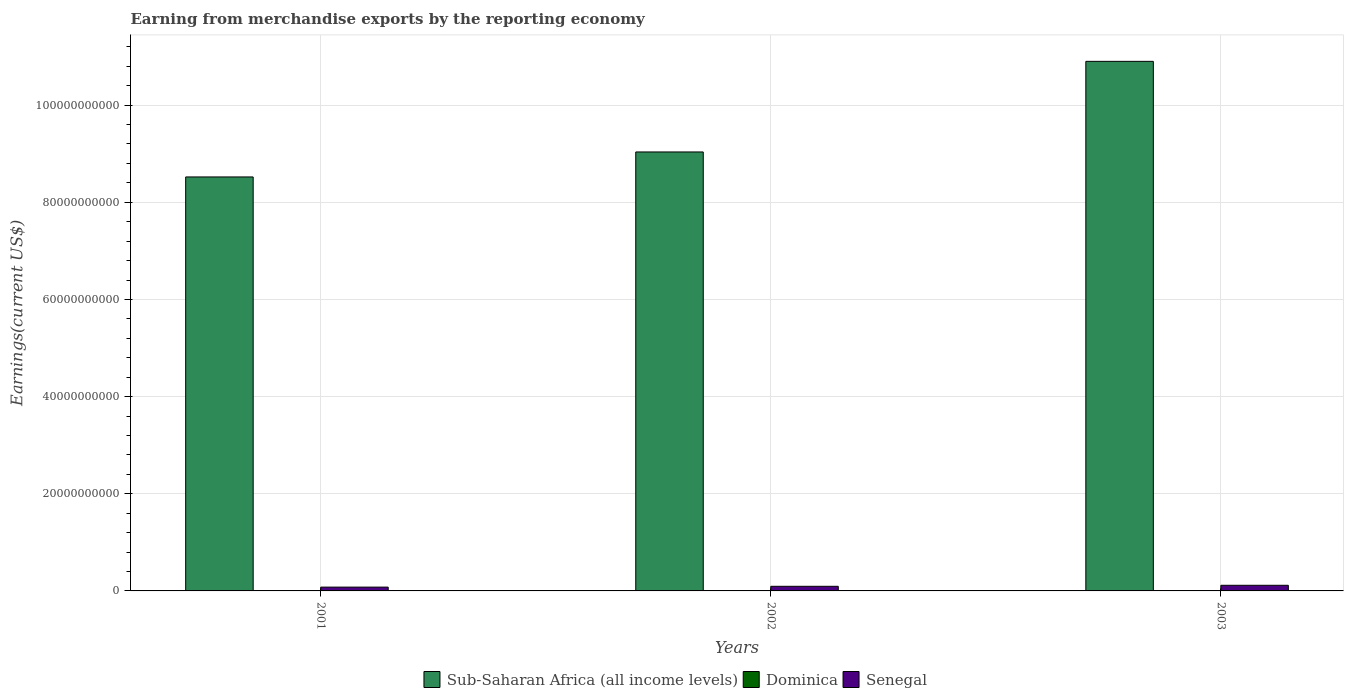How many different coloured bars are there?
Your response must be concise. 3. How many groups of bars are there?
Your answer should be compact. 3. What is the label of the 3rd group of bars from the left?
Offer a very short reply. 2003. In how many cases, is the number of bars for a given year not equal to the number of legend labels?
Provide a succinct answer. 0. What is the amount earned from merchandise exports in Dominica in 2003?
Provide a short and direct response. 6.10e+07. Across all years, what is the maximum amount earned from merchandise exports in Dominica?
Give a very brief answer. 6.10e+07. Across all years, what is the minimum amount earned from merchandise exports in Sub-Saharan Africa (all income levels)?
Ensure brevity in your answer.  8.52e+1. In which year was the amount earned from merchandise exports in Senegal maximum?
Your response must be concise. 2003. In which year was the amount earned from merchandise exports in Dominica minimum?
Keep it short and to the point. 2001. What is the total amount earned from merchandise exports in Senegal in the graph?
Offer a terse response. 2.89e+09. What is the difference between the amount earned from merchandise exports in Dominica in 2001 and that in 2002?
Your response must be concise. -1.71e+07. What is the difference between the amount earned from merchandise exports in Sub-Saharan Africa (all income levels) in 2003 and the amount earned from merchandise exports in Senegal in 2001?
Ensure brevity in your answer.  1.08e+11. What is the average amount earned from merchandise exports in Senegal per year?
Provide a short and direct response. 9.64e+08. In the year 2003, what is the difference between the amount earned from merchandise exports in Dominica and amount earned from merchandise exports in Sub-Saharan Africa (all income levels)?
Provide a short and direct response. -1.09e+11. What is the ratio of the amount earned from merchandise exports in Sub-Saharan Africa (all income levels) in 2001 to that in 2003?
Your answer should be very brief. 0.78. Is the difference between the amount earned from merchandise exports in Dominica in 2002 and 2003 greater than the difference between the amount earned from merchandise exports in Sub-Saharan Africa (all income levels) in 2002 and 2003?
Give a very brief answer. Yes. What is the difference between the highest and the second highest amount earned from merchandise exports in Senegal?
Offer a very short reply. 2.10e+08. What is the difference between the highest and the lowest amount earned from merchandise exports in Dominica?
Your answer should be very brief. 1.74e+07. Is the sum of the amount earned from merchandise exports in Sub-Saharan Africa (all income levels) in 2001 and 2002 greater than the maximum amount earned from merchandise exports in Senegal across all years?
Ensure brevity in your answer.  Yes. What does the 1st bar from the left in 2001 represents?
Provide a succinct answer. Sub-Saharan Africa (all income levels). What does the 3rd bar from the right in 2003 represents?
Offer a terse response. Sub-Saharan Africa (all income levels). How many bars are there?
Provide a succinct answer. 9. Are all the bars in the graph horizontal?
Your response must be concise. No. What is the difference between two consecutive major ticks on the Y-axis?
Make the answer very short. 2.00e+1. Are the values on the major ticks of Y-axis written in scientific E-notation?
Your answer should be compact. No. Does the graph contain any zero values?
Provide a succinct answer. No. How many legend labels are there?
Your response must be concise. 3. What is the title of the graph?
Your answer should be compact. Earning from merchandise exports by the reporting economy. Does "Bahrain" appear as one of the legend labels in the graph?
Provide a succinct answer. No. What is the label or title of the X-axis?
Ensure brevity in your answer.  Years. What is the label or title of the Y-axis?
Offer a terse response. Earnings(current US$). What is the Earnings(current US$) of Sub-Saharan Africa (all income levels) in 2001?
Give a very brief answer. 8.52e+1. What is the Earnings(current US$) in Dominica in 2001?
Make the answer very short. 4.35e+07. What is the Earnings(current US$) in Senegal in 2001?
Provide a succinct answer. 7.84e+08. What is the Earnings(current US$) of Sub-Saharan Africa (all income levels) in 2002?
Keep it short and to the point. 9.04e+1. What is the Earnings(current US$) in Dominica in 2002?
Keep it short and to the point. 6.06e+07. What is the Earnings(current US$) in Senegal in 2002?
Offer a very short reply. 9.49e+08. What is the Earnings(current US$) in Sub-Saharan Africa (all income levels) in 2003?
Your answer should be compact. 1.09e+11. What is the Earnings(current US$) of Dominica in 2003?
Keep it short and to the point. 6.10e+07. What is the Earnings(current US$) of Senegal in 2003?
Your response must be concise. 1.16e+09. Across all years, what is the maximum Earnings(current US$) in Sub-Saharan Africa (all income levels)?
Make the answer very short. 1.09e+11. Across all years, what is the maximum Earnings(current US$) in Dominica?
Provide a short and direct response. 6.10e+07. Across all years, what is the maximum Earnings(current US$) in Senegal?
Make the answer very short. 1.16e+09. Across all years, what is the minimum Earnings(current US$) of Sub-Saharan Africa (all income levels)?
Offer a very short reply. 8.52e+1. Across all years, what is the minimum Earnings(current US$) in Dominica?
Your answer should be very brief. 4.35e+07. Across all years, what is the minimum Earnings(current US$) in Senegal?
Your response must be concise. 7.84e+08. What is the total Earnings(current US$) in Sub-Saharan Africa (all income levels) in the graph?
Offer a terse response. 2.85e+11. What is the total Earnings(current US$) in Dominica in the graph?
Give a very brief answer. 1.65e+08. What is the total Earnings(current US$) of Senegal in the graph?
Make the answer very short. 2.89e+09. What is the difference between the Earnings(current US$) in Sub-Saharan Africa (all income levels) in 2001 and that in 2002?
Keep it short and to the point. -5.14e+09. What is the difference between the Earnings(current US$) in Dominica in 2001 and that in 2002?
Offer a terse response. -1.71e+07. What is the difference between the Earnings(current US$) of Senegal in 2001 and that in 2002?
Make the answer very short. -1.65e+08. What is the difference between the Earnings(current US$) of Sub-Saharan Africa (all income levels) in 2001 and that in 2003?
Your answer should be very brief. -2.38e+1. What is the difference between the Earnings(current US$) in Dominica in 2001 and that in 2003?
Provide a short and direct response. -1.74e+07. What is the difference between the Earnings(current US$) in Senegal in 2001 and that in 2003?
Your answer should be compact. -3.75e+08. What is the difference between the Earnings(current US$) in Sub-Saharan Africa (all income levels) in 2002 and that in 2003?
Give a very brief answer. -1.86e+1. What is the difference between the Earnings(current US$) in Dominica in 2002 and that in 2003?
Make the answer very short. -3.49e+05. What is the difference between the Earnings(current US$) in Senegal in 2002 and that in 2003?
Your answer should be compact. -2.10e+08. What is the difference between the Earnings(current US$) in Sub-Saharan Africa (all income levels) in 2001 and the Earnings(current US$) in Dominica in 2002?
Keep it short and to the point. 8.52e+1. What is the difference between the Earnings(current US$) of Sub-Saharan Africa (all income levels) in 2001 and the Earnings(current US$) of Senegal in 2002?
Provide a short and direct response. 8.43e+1. What is the difference between the Earnings(current US$) in Dominica in 2001 and the Earnings(current US$) in Senegal in 2002?
Your answer should be compact. -9.05e+08. What is the difference between the Earnings(current US$) in Sub-Saharan Africa (all income levels) in 2001 and the Earnings(current US$) in Dominica in 2003?
Keep it short and to the point. 8.52e+1. What is the difference between the Earnings(current US$) in Sub-Saharan Africa (all income levels) in 2001 and the Earnings(current US$) in Senegal in 2003?
Ensure brevity in your answer.  8.41e+1. What is the difference between the Earnings(current US$) of Dominica in 2001 and the Earnings(current US$) of Senegal in 2003?
Offer a very short reply. -1.12e+09. What is the difference between the Earnings(current US$) of Sub-Saharan Africa (all income levels) in 2002 and the Earnings(current US$) of Dominica in 2003?
Keep it short and to the point. 9.03e+1. What is the difference between the Earnings(current US$) in Sub-Saharan Africa (all income levels) in 2002 and the Earnings(current US$) in Senegal in 2003?
Give a very brief answer. 8.92e+1. What is the difference between the Earnings(current US$) of Dominica in 2002 and the Earnings(current US$) of Senegal in 2003?
Provide a succinct answer. -1.10e+09. What is the average Earnings(current US$) of Sub-Saharan Africa (all income levels) per year?
Your answer should be very brief. 9.49e+1. What is the average Earnings(current US$) of Dominica per year?
Ensure brevity in your answer.  5.50e+07. What is the average Earnings(current US$) in Senegal per year?
Keep it short and to the point. 9.64e+08. In the year 2001, what is the difference between the Earnings(current US$) in Sub-Saharan Africa (all income levels) and Earnings(current US$) in Dominica?
Your answer should be very brief. 8.52e+1. In the year 2001, what is the difference between the Earnings(current US$) in Sub-Saharan Africa (all income levels) and Earnings(current US$) in Senegal?
Make the answer very short. 8.44e+1. In the year 2001, what is the difference between the Earnings(current US$) of Dominica and Earnings(current US$) of Senegal?
Offer a terse response. -7.40e+08. In the year 2002, what is the difference between the Earnings(current US$) in Sub-Saharan Africa (all income levels) and Earnings(current US$) in Dominica?
Offer a very short reply. 9.03e+1. In the year 2002, what is the difference between the Earnings(current US$) of Sub-Saharan Africa (all income levels) and Earnings(current US$) of Senegal?
Make the answer very short. 8.94e+1. In the year 2002, what is the difference between the Earnings(current US$) of Dominica and Earnings(current US$) of Senegal?
Your answer should be compact. -8.88e+08. In the year 2003, what is the difference between the Earnings(current US$) in Sub-Saharan Africa (all income levels) and Earnings(current US$) in Dominica?
Make the answer very short. 1.09e+11. In the year 2003, what is the difference between the Earnings(current US$) in Sub-Saharan Africa (all income levels) and Earnings(current US$) in Senegal?
Ensure brevity in your answer.  1.08e+11. In the year 2003, what is the difference between the Earnings(current US$) in Dominica and Earnings(current US$) in Senegal?
Offer a terse response. -1.10e+09. What is the ratio of the Earnings(current US$) of Sub-Saharan Africa (all income levels) in 2001 to that in 2002?
Your answer should be compact. 0.94. What is the ratio of the Earnings(current US$) of Dominica in 2001 to that in 2002?
Your answer should be compact. 0.72. What is the ratio of the Earnings(current US$) of Senegal in 2001 to that in 2002?
Give a very brief answer. 0.83. What is the ratio of the Earnings(current US$) of Sub-Saharan Africa (all income levels) in 2001 to that in 2003?
Give a very brief answer. 0.78. What is the ratio of the Earnings(current US$) of Dominica in 2001 to that in 2003?
Provide a short and direct response. 0.71. What is the ratio of the Earnings(current US$) in Senegal in 2001 to that in 2003?
Ensure brevity in your answer.  0.68. What is the ratio of the Earnings(current US$) of Sub-Saharan Africa (all income levels) in 2002 to that in 2003?
Your answer should be very brief. 0.83. What is the ratio of the Earnings(current US$) in Senegal in 2002 to that in 2003?
Your answer should be very brief. 0.82. What is the difference between the highest and the second highest Earnings(current US$) of Sub-Saharan Africa (all income levels)?
Provide a short and direct response. 1.86e+1. What is the difference between the highest and the second highest Earnings(current US$) in Dominica?
Provide a succinct answer. 3.49e+05. What is the difference between the highest and the second highest Earnings(current US$) of Senegal?
Offer a terse response. 2.10e+08. What is the difference between the highest and the lowest Earnings(current US$) in Sub-Saharan Africa (all income levels)?
Give a very brief answer. 2.38e+1. What is the difference between the highest and the lowest Earnings(current US$) of Dominica?
Make the answer very short. 1.74e+07. What is the difference between the highest and the lowest Earnings(current US$) in Senegal?
Give a very brief answer. 3.75e+08. 